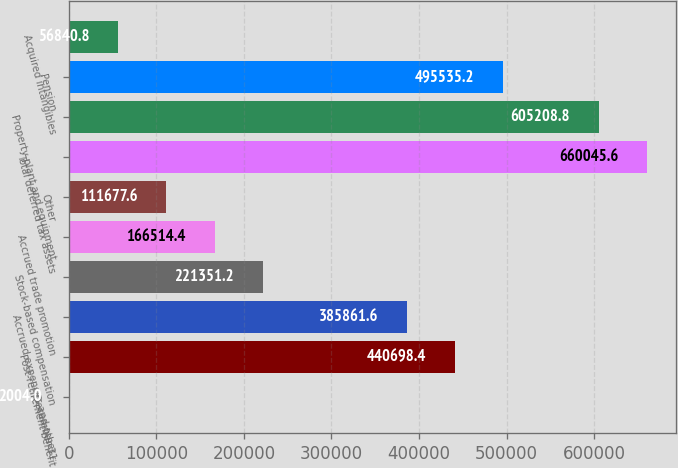Convert chart to OTSL. <chart><loc_0><loc_0><loc_500><loc_500><bar_chart><fcel>December 31<fcel>Post-retirement benefit<fcel>Accrued expenses and other<fcel>Stock-based compensation<fcel>Accrued trade promotion<fcel>Other<fcel>Total deferred tax assets<fcel>Property plant and equipment<fcel>Pension<fcel>Acquired intangibles<nl><fcel>2004<fcel>440698<fcel>385862<fcel>221351<fcel>166514<fcel>111678<fcel>660046<fcel>605209<fcel>495535<fcel>56840.8<nl></chart> 